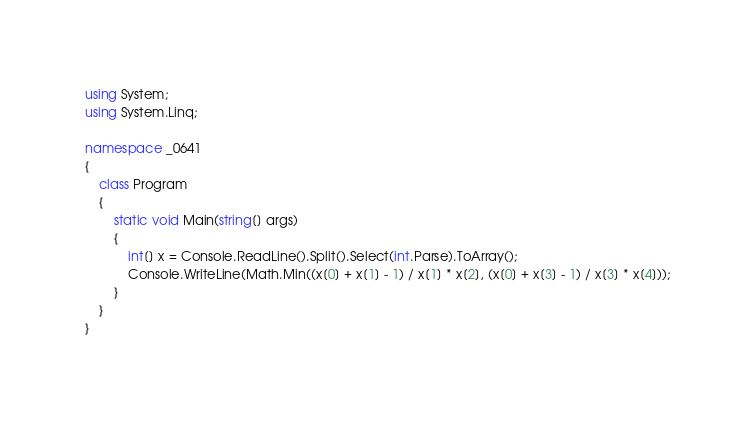Convert code to text. <code><loc_0><loc_0><loc_500><loc_500><_C#_>using System;
using System.Linq;

namespace _0641
{
    class Program
    {
        static void Main(string[] args)
        {
            int[] x = Console.ReadLine().Split().Select(int.Parse).ToArray();
            Console.WriteLine(Math.Min((x[0] + x[1] - 1) / x[1] * x[2], (x[0] + x[3] - 1) / x[3] * x[4]));
        }
    }
}

</code> 